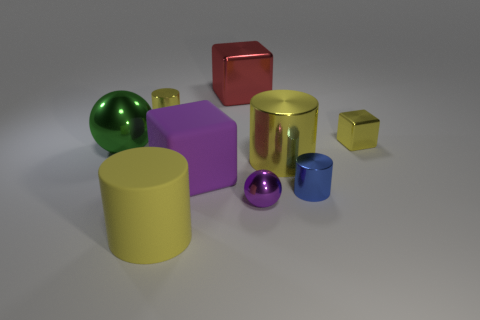Subtract all shiny blocks. How many blocks are left? 1 Add 1 tiny blue objects. How many objects exist? 10 Subtract 1 balls. How many balls are left? 1 Subtract all cyan balls. How many yellow cylinders are left? 3 Subtract all purple balls. How many balls are left? 1 Subtract all blocks. How many objects are left? 6 Subtract all yellow cylinders. Subtract all brown spheres. How many cylinders are left? 1 Subtract all tiny metallic balls. Subtract all large purple objects. How many objects are left? 7 Add 8 small shiny cylinders. How many small shiny cylinders are left? 10 Add 3 tiny gray spheres. How many tiny gray spheres exist? 3 